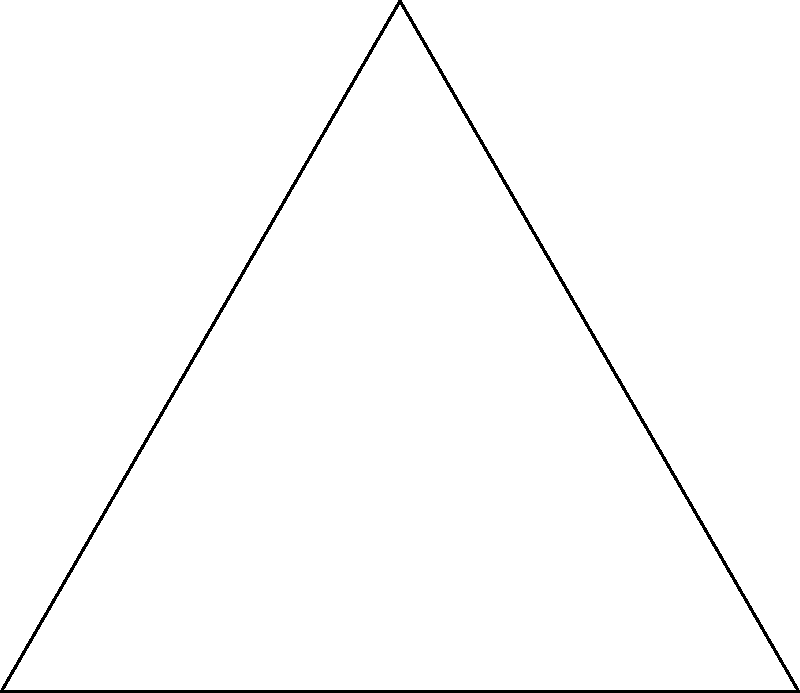In an equilateral triangle ABC with side length $a$, a circle is inscribed such that it touches all three sides of the triangle. Determine the radius $r$ of this inscribed circle in terms of $a$. Let's approach this step-by-step:

1) In an equilateral triangle, all sides are equal and all angles are 60°.

2) Let's draw a line from the center of the inscribed circle (O) to one of the vertices (A) and to the point where the circle touches the opposite side.

3) This creates a right triangle. Let's call the point where the circle touches the side D.

4) In this right triangle OAD:
   - OA is the radius of the circumscribed circle of the equilateral triangle
   - OD is the radius of the inscribed circle (r)
   - AD is the difference between these two radii

5) We know that in an equilateral triangle:
   - The radius of the circumscribed circle is $\frac{a}{\sqrt{3}}$
   - The radius of the inscribed circle is what we're trying to find (r)

6) In the right triangle OAD:
   $\cos 30° = \frac{r}{\frac{a}{\sqrt{3}}}$

7) We know that $\cos 30° = \frac{\sqrt{3}}{2}$

8) Substituting:
   $\frac{\sqrt{3}}{2} = \frac{r}{\frac{a}{\sqrt{3}}}$

9) Cross multiply:
   $\frac{\sqrt{3}}{2} \cdot \frac{a}{\sqrt{3}} = r$

10) Simplify:
    $\frac{a}{2} = r$

Therefore, the radius of the inscribed circle is half the side length of the equilateral triangle.
Answer: $r = \frac{a}{2}$ 